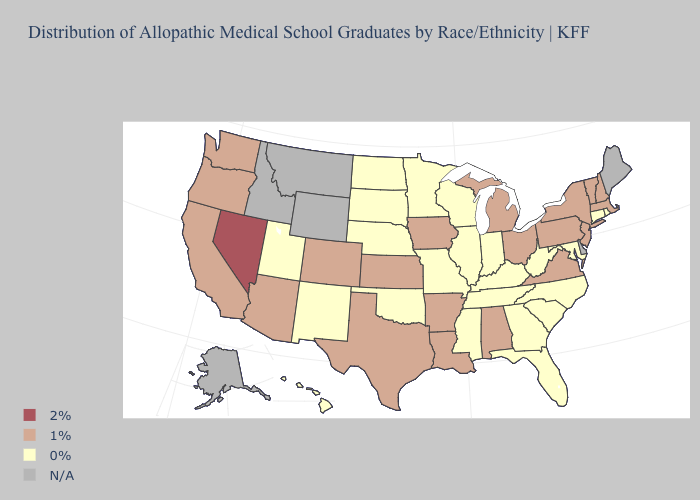Which states have the lowest value in the USA?
Be succinct. Connecticut, Florida, Georgia, Hawaii, Illinois, Indiana, Kentucky, Maryland, Minnesota, Mississippi, Missouri, Nebraska, New Mexico, North Carolina, North Dakota, Oklahoma, Rhode Island, South Carolina, South Dakota, Tennessee, Utah, West Virginia, Wisconsin. Name the states that have a value in the range 1%?
Quick response, please. Alabama, Arizona, Arkansas, California, Colorado, Iowa, Kansas, Louisiana, Massachusetts, Michigan, New Hampshire, New Jersey, New York, Ohio, Oregon, Pennsylvania, Texas, Vermont, Virginia, Washington. What is the lowest value in the USA?
Short answer required. 0%. Name the states that have a value in the range N/A?
Keep it brief. Alaska, Delaware, Idaho, Maine, Montana, Wyoming. What is the value of Maine?
Write a very short answer. N/A. What is the value of Oklahoma?
Quick response, please. 0%. What is the value of Kentucky?
Concise answer only. 0%. Does the map have missing data?
Quick response, please. Yes. What is the value of Louisiana?
Write a very short answer. 1%. What is the lowest value in the USA?
Answer briefly. 0%. Name the states that have a value in the range 1%?
Answer briefly. Alabama, Arizona, Arkansas, California, Colorado, Iowa, Kansas, Louisiana, Massachusetts, Michigan, New Hampshire, New Jersey, New York, Ohio, Oregon, Pennsylvania, Texas, Vermont, Virginia, Washington. Does the map have missing data?
Answer briefly. Yes. Among the states that border Wyoming , does South Dakota have the lowest value?
Write a very short answer. Yes. 